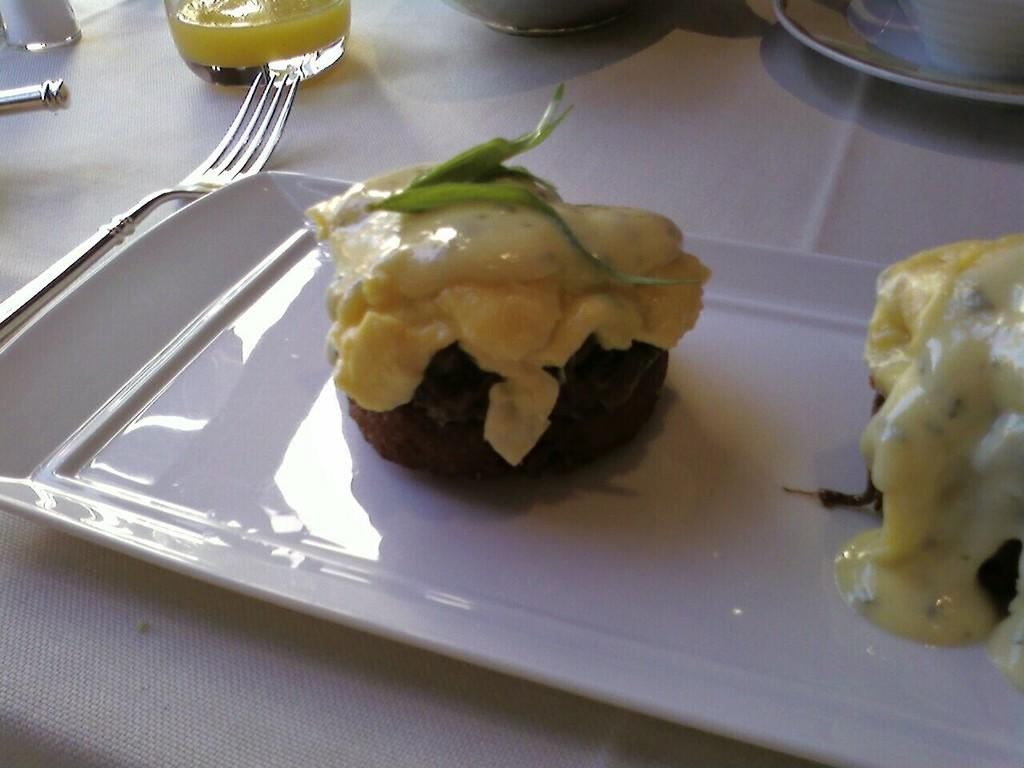What is on the white plate in the image? There is food on a white plate in the image. What colors can be seen in the food? The food has green, cream, and black colors. What utensil is visible in the image? There is a fork visible in the image. What else can be seen on the table in the image? There are objects on the table in the image. What type of story is being told by the stove in the image? There is no stove present in the image, so no story can be told by it. 